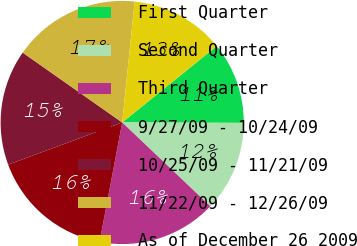Convert chart. <chart><loc_0><loc_0><loc_500><loc_500><pie_chart><fcel>First Quarter<fcel>Second Quarter<fcel>Third Quarter<fcel>9/27/09 - 10/24/09<fcel>10/25/09 - 11/21/09<fcel>11/22/09 - 12/26/09<fcel>As of December 26 2009<nl><fcel>10.87%<fcel>12.05%<fcel>15.88%<fcel>16.38%<fcel>15.38%<fcel>16.89%<fcel>12.55%<nl></chart> 